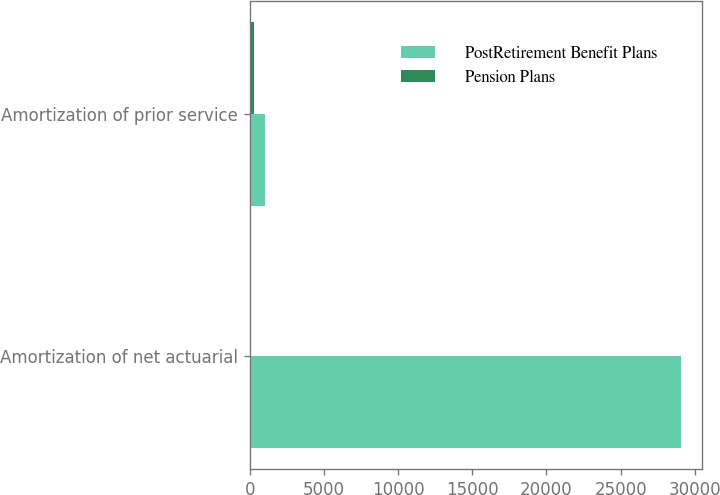<chart> <loc_0><loc_0><loc_500><loc_500><stacked_bar_chart><ecel><fcel>Amortization of net actuarial<fcel>Amortization of prior service<nl><fcel>PostRetirement Benefit Plans<fcel>29052<fcel>1006<nl><fcel>Pension Plans<fcel>23<fcel>276<nl></chart> 